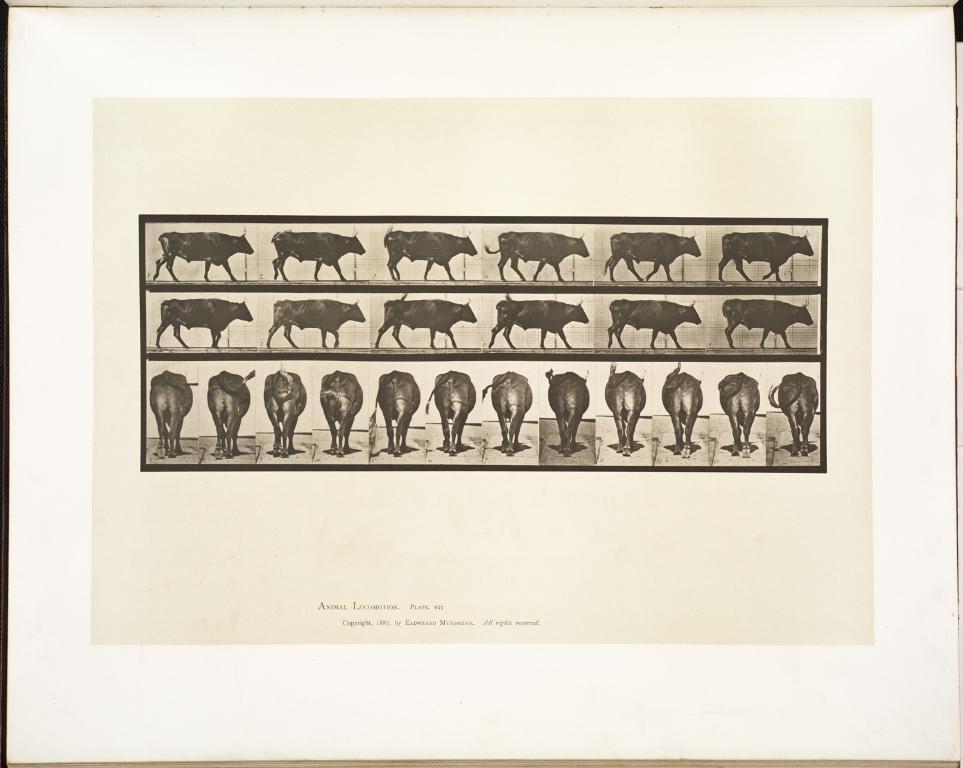What is the main object in the image? There is a poster in the image. What can be seen on the poster? The poster contains different pictures of an animal. Is there any text on the poster? No, the text is written at the bottom of the image, not on the poster itself. What message of peace does the poster convey? The poster does not convey a message of peace, as it only contains pictures of an animal and no text related to peace. 